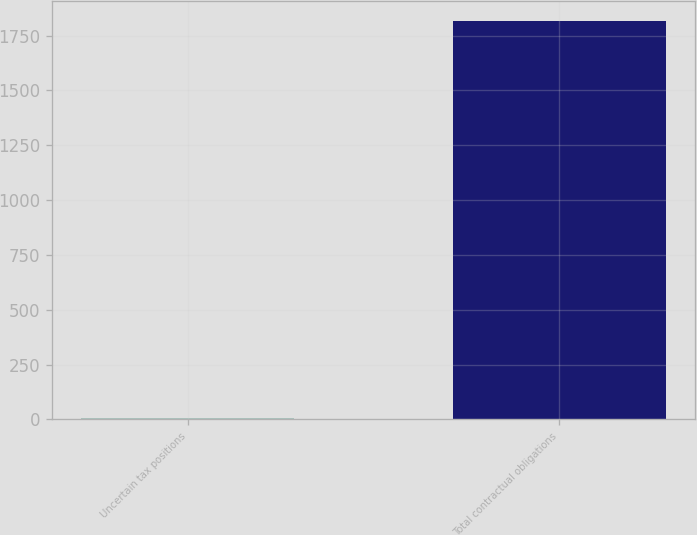<chart> <loc_0><loc_0><loc_500><loc_500><bar_chart><fcel>Uncertain tax positions<fcel>Total contractual obligations<nl><fcel>6.5<fcel>1815.3<nl></chart> 